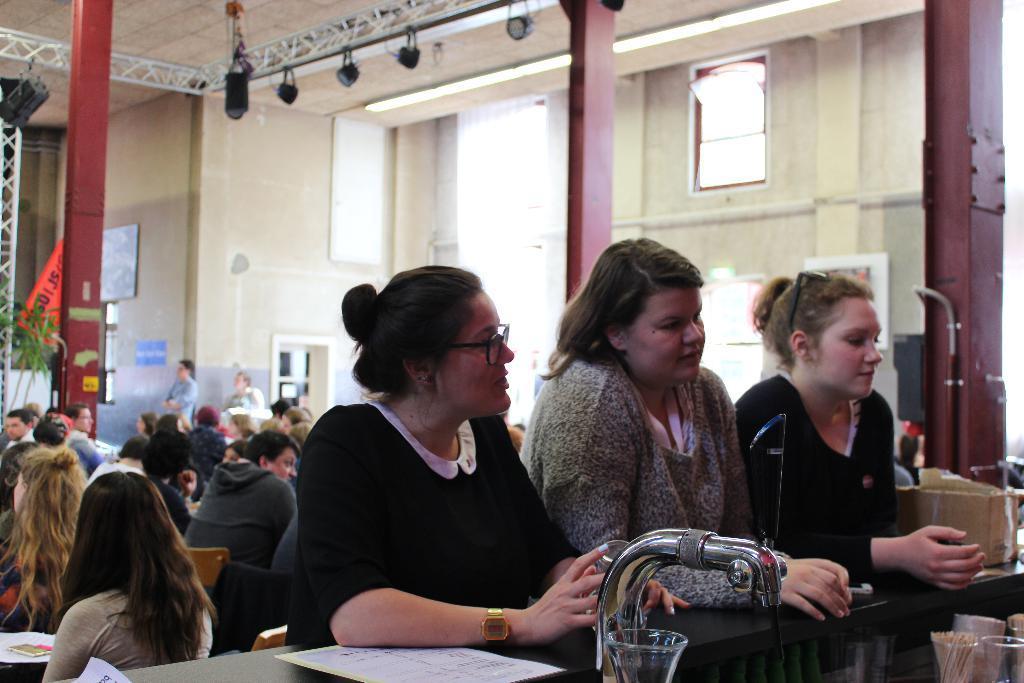Can you describe this image briefly? In this image I can see a group of people are sitting on the chairs in front of tables and few are standing on the floor in front of a cabinet. In the background I can see a wall, windows, houseplants, pillars, metal rods and lights. This image is taken may be in a hall. 